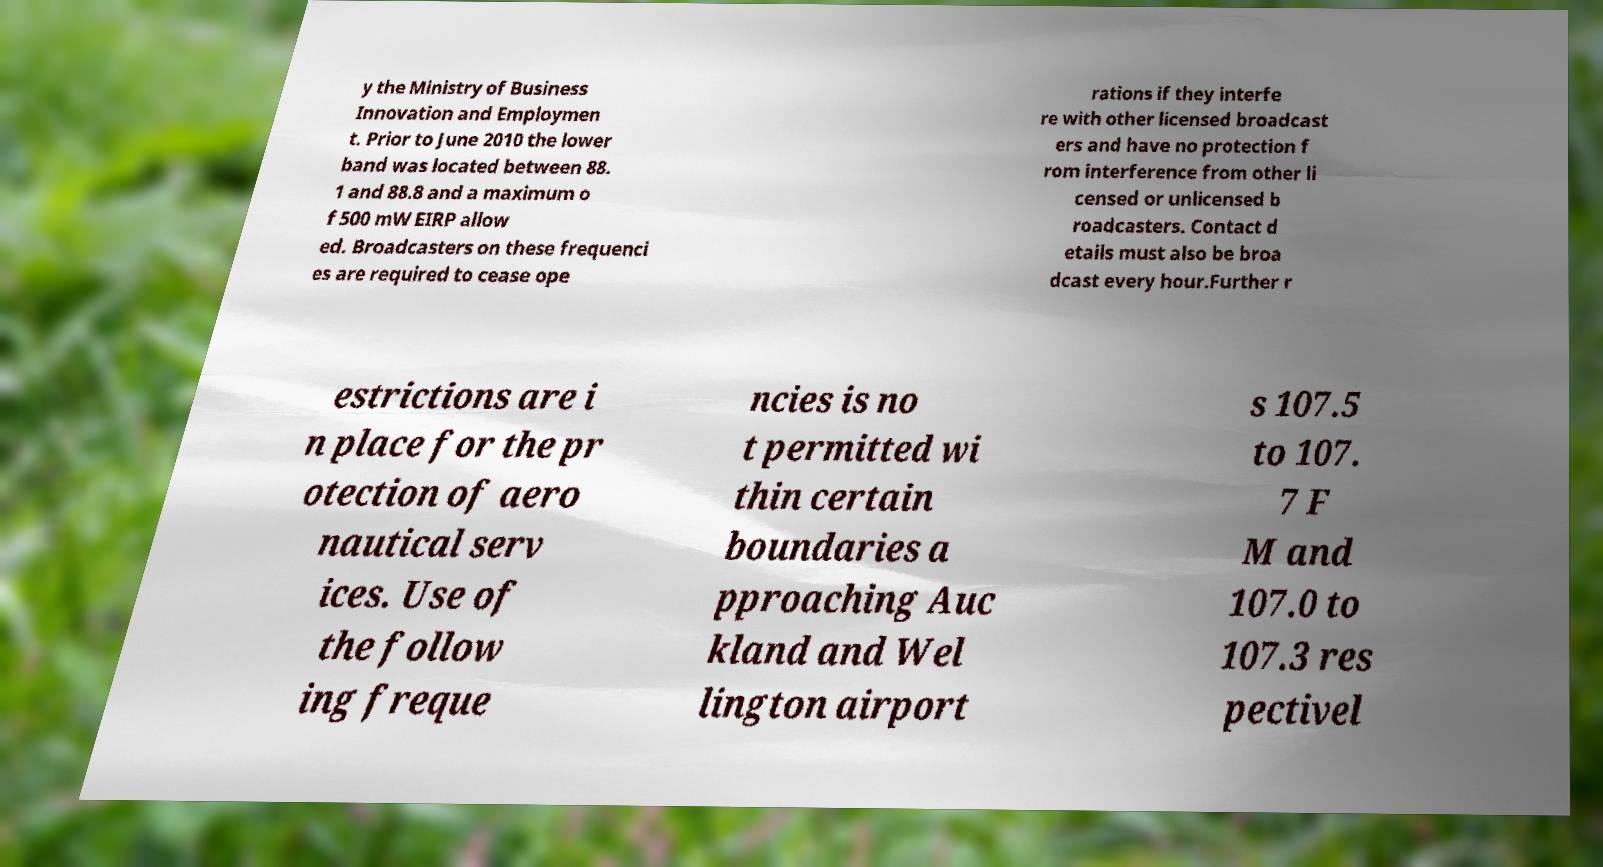There's text embedded in this image that I need extracted. Can you transcribe it verbatim? y the Ministry of Business Innovation and Employmen t. Prior to June 2010 the lower band was located between 88. 1 and 88.8 and a maximum o f 500 mW EIRP allow ed. Broadcasters on these frequenci es are required to cease ope rations if they interfe re with other licensed broadcast ers and have no protection f rom interference from other li censed or unlicensed b roadcasters. Contact d etails must also be broa dcast every hour.Further r estrictions are i n place for the pr otection of aero nautical serv ices. Use of the follow ing freque ncies is no t permitted wi thin certain boundaries a pproaching Auc kland and Wel lington airport s 107.5 to 107. 7 F M and 107.0 to 107.3 res pectivel 